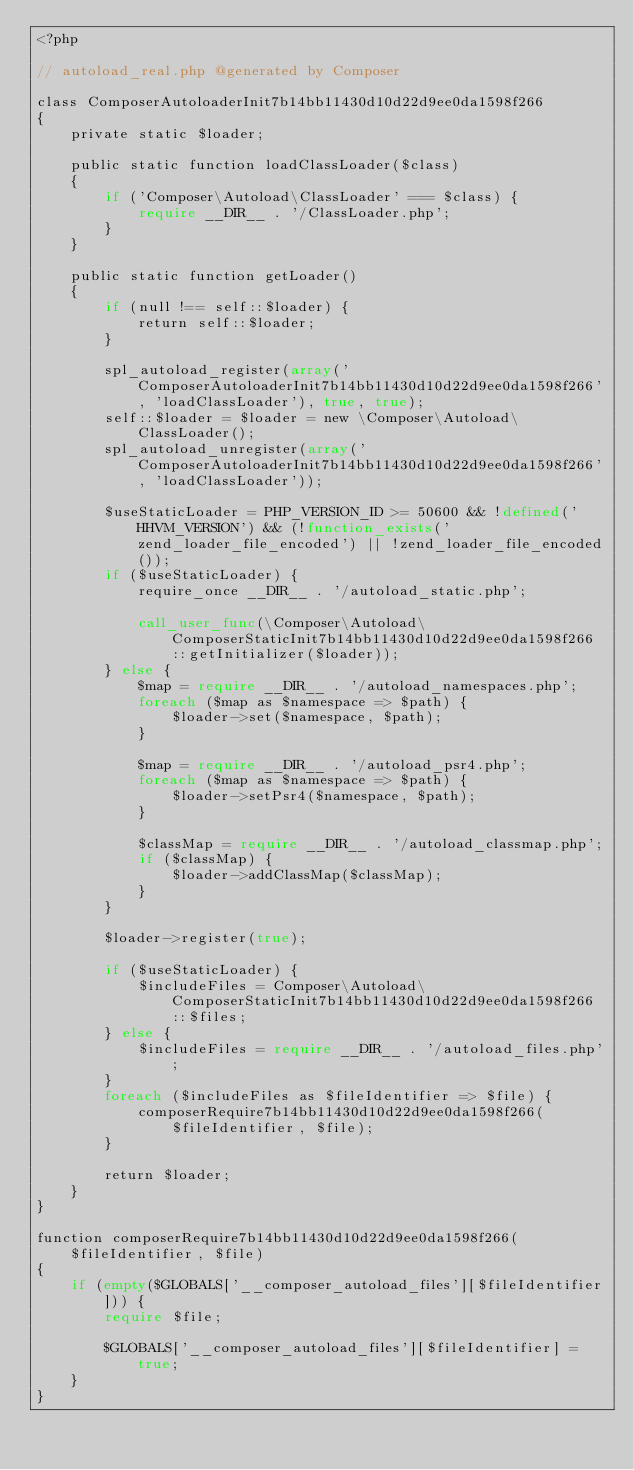<code> <loc_0><loc_0><loc_500><loc_500><_PHP_><?php

// autoload_real.php @generated by Composer

class ComposerAutoloaderInit7b14bb11430d10d22d9ee0da1598f266
{
    private static $loader;

    public static function loadClassLoader($class)
    {
        if ('Composer\Autoload\ClassLoader' === $class) {
            require __DIR__ . '/ClassLoader.php';
        }
    }

    public static function getLoader()
    {
        if (null !== self::$loader) {
            return self::$loader;
        }

        spl_autoload_register(array('ComposerAutoloaderInit7b14bb11430d10d22d9ee0da1598f266', 'loadClassLoader'), true, true);
        self::$loader = $loader = new \Composer\Autoload\ClassLoader();
        spl_autoload_unregister(array('ComposerAutoloaderInit7b14bb11430d10d22d9ee0da1598f266', 'loadClassLoader'));

        $useStaticLoader = PHP_VERSION_ID >= 50600 && !defined('HHVM_VERSION') && (!function_exists('zend_loader_file_encoded') || !zend_loader_file_encoded());
        if ($useStaticLoader) {
            require_once __DIR__ . '/autoload_static.php';

            call_user_func(\Composer\Autoload\ComposerStaticInit7b14bb11430d10d22d9ee0da1598f266::getInitializer($loader));
        } else {
            $map = require __DIR__ . '/autoload_namespaces.php';
            foreach ($map as $namespace => $path) {
                $loader->set($namespace, $path);
            }

            $map = require __DIR__ . '/autoload_psr4.php';
            foreach ($map as $namespace => $path) {
                $loader->setPsr4($namespace, $path);
            }

            $classMap = require __DIR__ . '/autoload_classmap.php';
            if ($classMap) {
                $loader->addClassMap($classMap);
            }
        }

        $loader->register(true);

        if ($useStaticLoader) {
            $includeFiles = Composer\Autoload\ComposerStaticInit7b14bb11430d10d22d9ee0da1598f266::$files;
        } else {
            $includeFiles = require __DIR__ . '/autoload_files.php';
        }
        foreach ($includeFiles as $fileIdentifier => $file) {
            composerRequire7b14bb11430d10d22d9ee0da1598f266($fileIdentifier, $file);
        }

        return $loader;
    }
}

function composerRequire7b14bb11430d10d22d9ee0da1598f266($fileIdentifier, $file)
{
    if (empty($GLOBALS['__composer_autoload_files'][$fileIdentifier])) {
        require $file;

        $GLOBALS['__composer_autoload_files'][$fileIdentifier] = true;
    }
}
</code> 